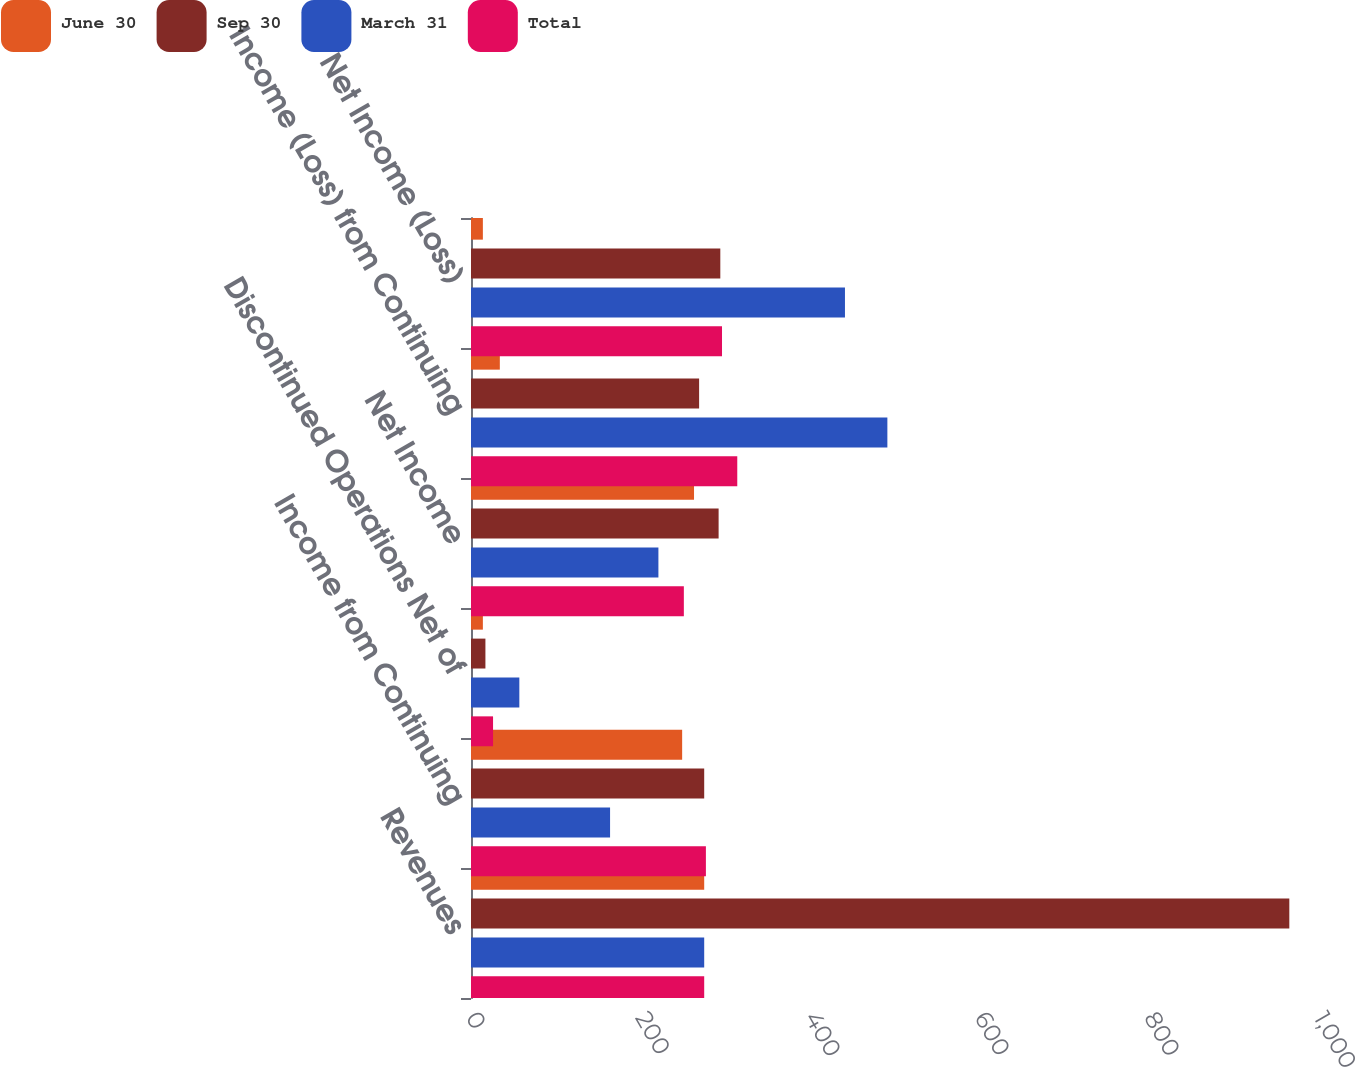Convert chart to OTSL. <chart><loc_0><loc_0><loc_500><loc_500><stacked_bar_chart><ecel><fcel>Revenues<fcel>Income from Continuing<fcel>Discontinued Operations Net of<fcel>Net Income<fcel>Income (Loss) from Continuing<fcel>Net Income (Loss)<nl><fcel>June 30<fcel>275<fcel>249<fcel>14<fcel>263<fcel>34<fcel>14<nl><fcel>Sep 30<fcel>965<fcel>275<fcel>17<fcel>292<fcel>269<fcel>294<nl><fcel>March 31<fcel>275<fcel>164<fcel>57<fcel>221<fcel>491<fcel>441<nl><fcel>Total<fcel>275<fcel>277<fcel>26<fcel>251<fcel>314<fcel>296<nl></chart> 